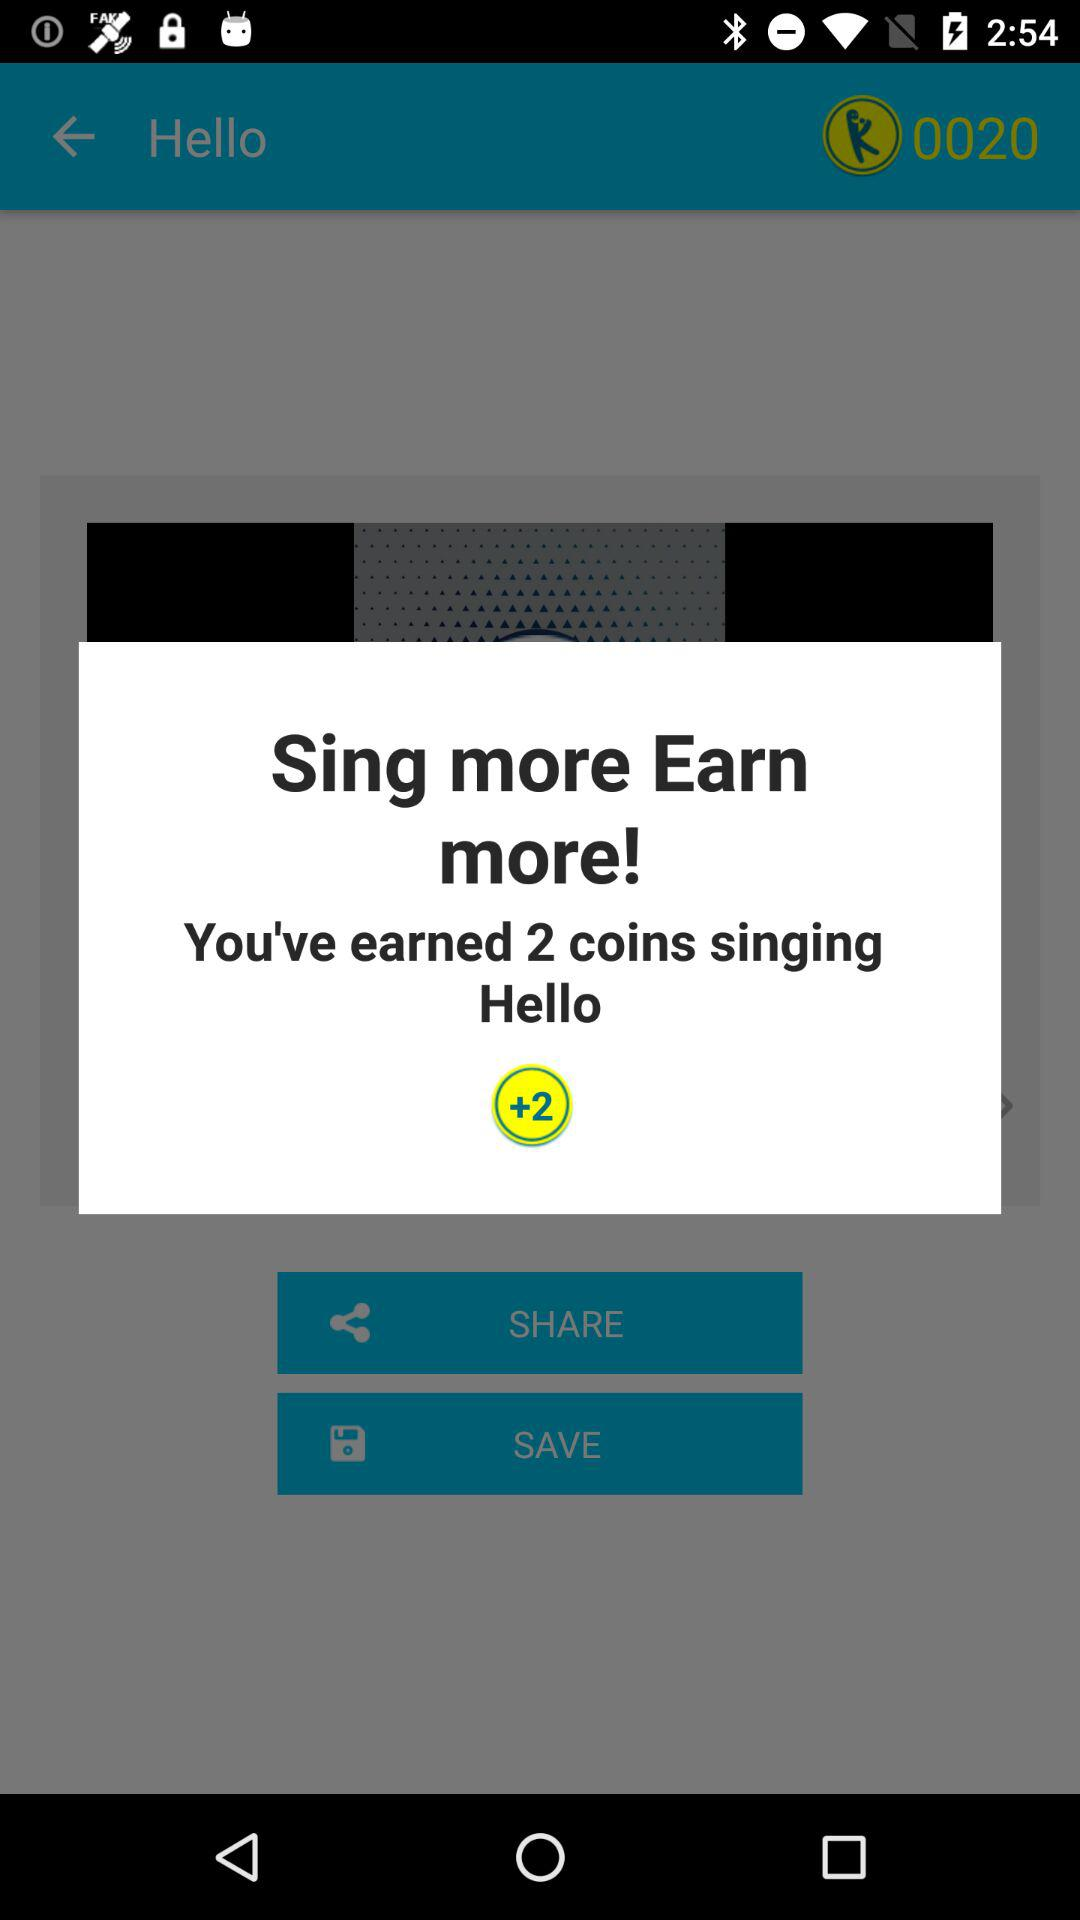How many more coins will I earn if I sing Hello again?
Answer the question using a single word or phrase. 2 